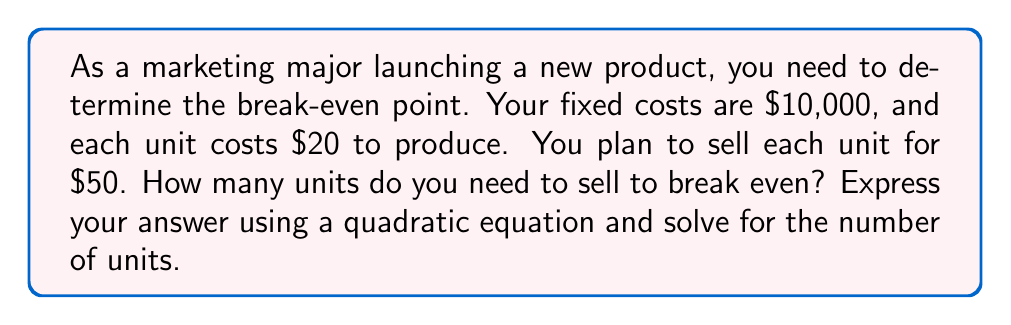Provide a solution to this math problem. Let's approach this step-by-step:

1) First, let's define our variables:
   $x$ = number of units sold
   $R$ = Revenue
   $C$ = Total Cost

2) We can express Revenue as: $R = 50x$ (price per unit * number of units)

3) Total Cost is the sum of fixed costs and variable costs:
   $C = 10000 + 20x$ (fixed cost + (cost per unit * number of units))

4) At the break-even point, Revenue equals Total Cost:
   $R = C$
   $50x = 10000 + 20x$

5) Rearrange the equation to standard quadratic form:
   $50x - 20x = 10000$
   $30x = 10000$
   $x = \frac{10000}{30}$
   $x = \frac{1000}{3}$

6) Therefore, you need to sell $\frac{1000}{3}$ units to break even.

7) We can verify this:
   Revenue: $50 * \frac{1000}{3} = \frac{50000}{3} = 16666.67$
   Cost: $10000 + 20 * \frac{1000}{3} = 10000 + \frac{20000}{3} = 16666.67$

   Revenue equals Cost, confirming the break-even point.
Answer: $\frac{1000}{3}$ units 